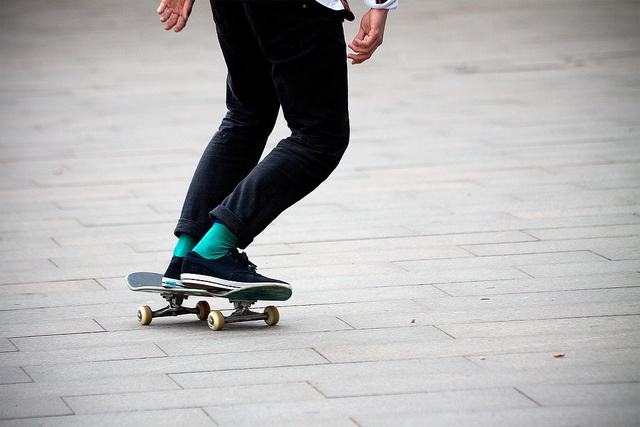Describe the objects in this image and their specific colors. I can see people in gray, black, lightgray, and darkgray tones and skateboard in gray, black, and lightgray tones in this image. 